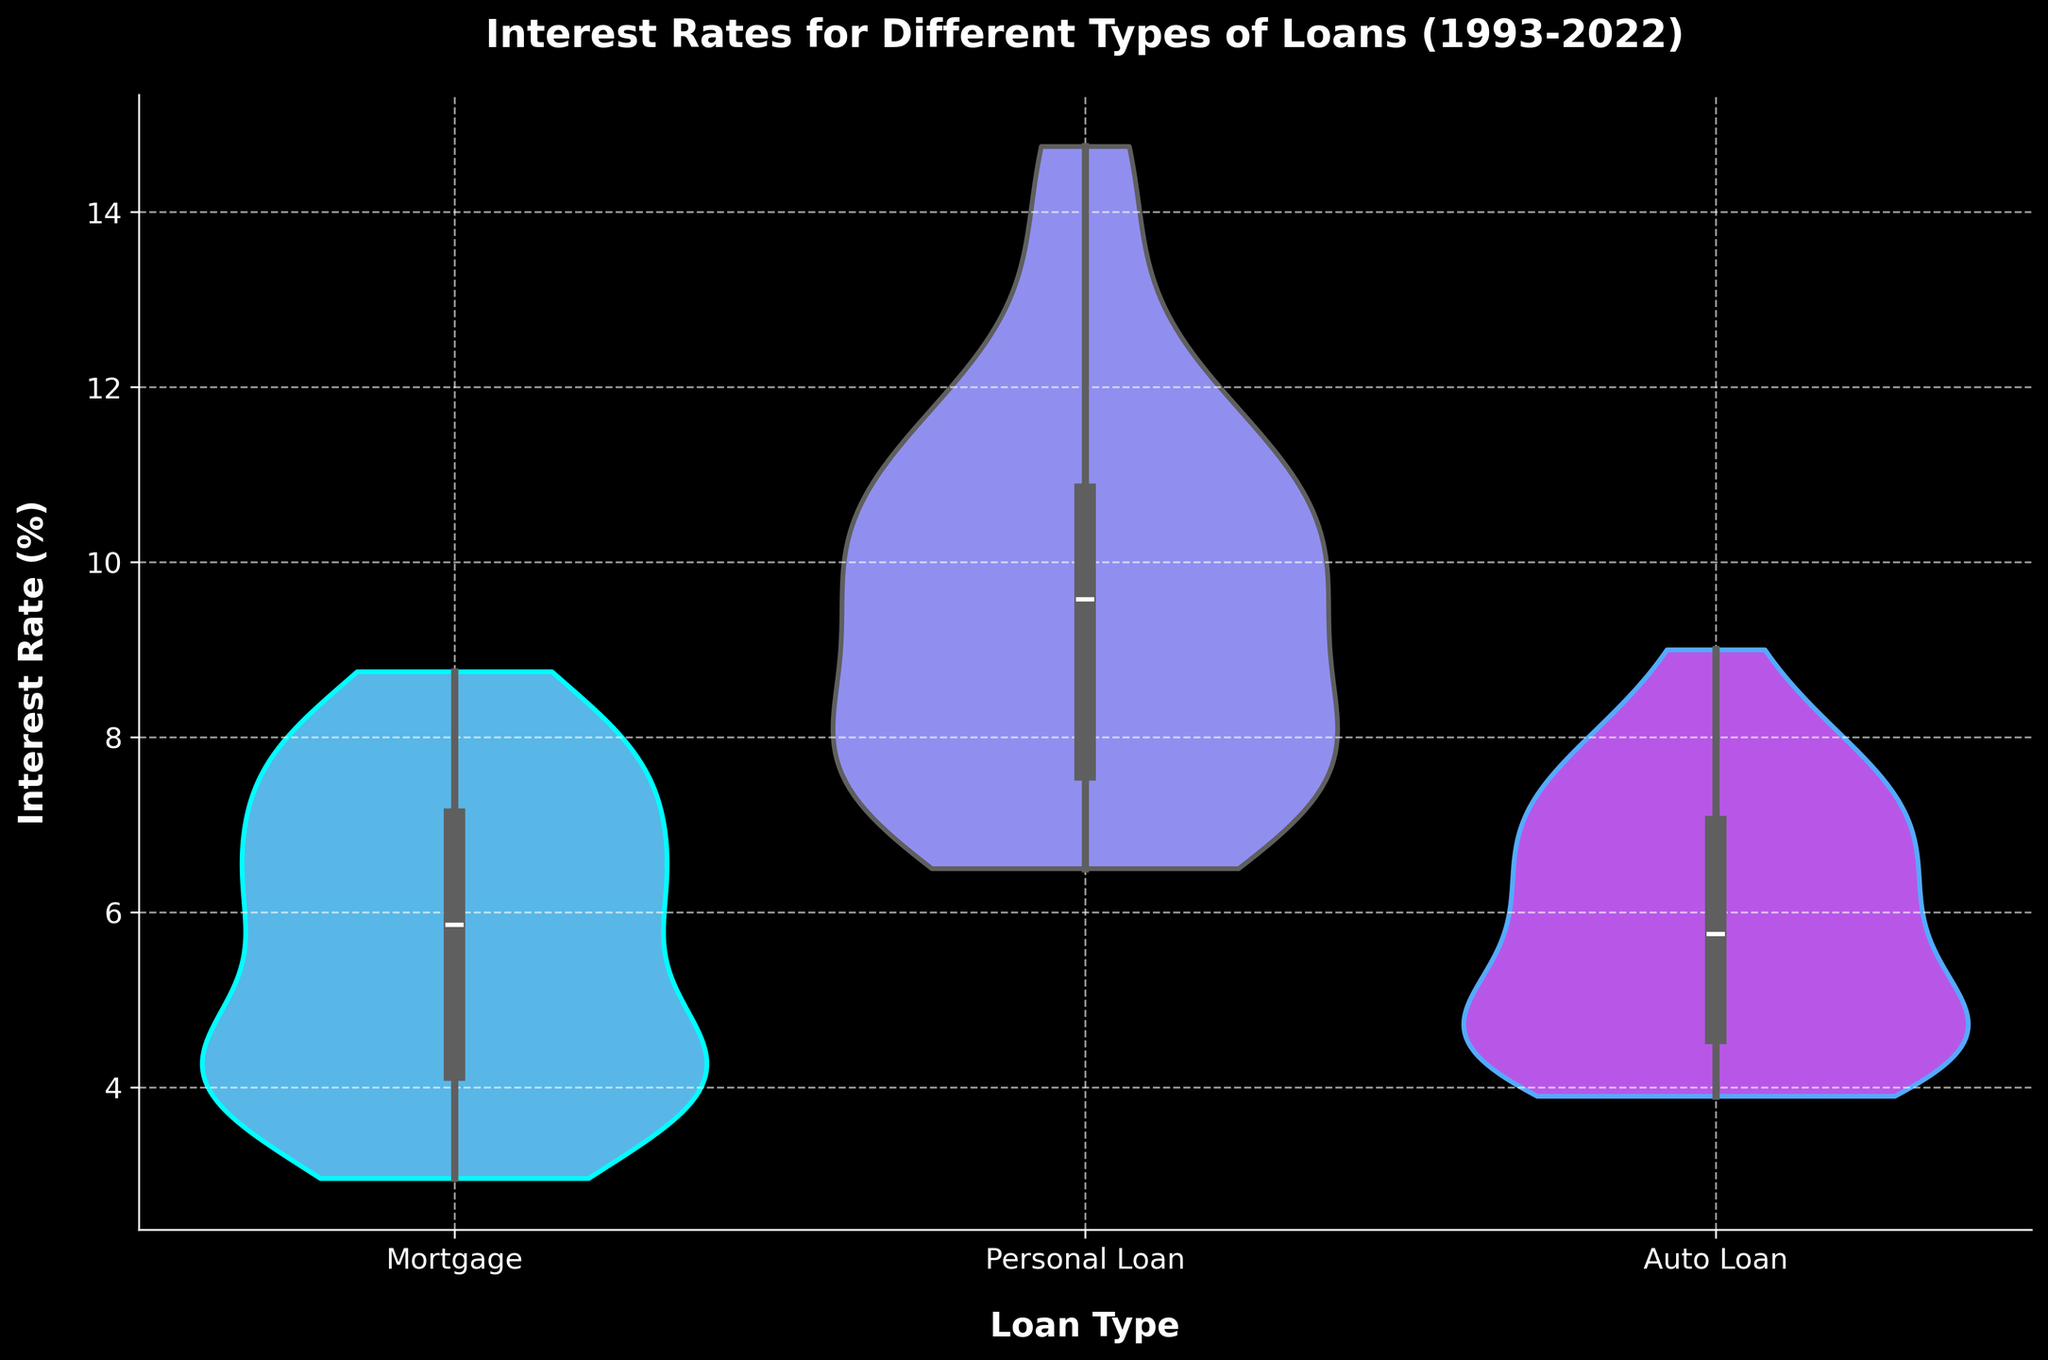what is the title of the figure? The title is usually displayed at the top of the figure. In this figure, it is clearly stated as 'Interest Rates for Different Types of Loans (1993-2022)'.
Answer: Interest Rates for Different Types of Loans (1993-2022) how many loan types are depicted in the figure? Each violin plot represents a different loan type. Counting the violin plots across the x-axis, we see three loan types.
Answer: Three which loan type has the widest spread in interest rates? The width of the violin plot indicates the distribution spread. The personal loan appears to have the widest spread compared to mortgages and auto loans.
Answer: Personal Loan which loan type has the lowest median interest rate? The median is represented by the middle line in the box plot overlay within each violin plot. Mortgage rates show the lowest median among the three loan types.
Answer: Mortgage which loan type exhibits the most variability (largest range) in interest rates? The range is the difference between the highest and lowest points within the violin plot. The auto loan has a significant spread especially in recent years, indicating the most variability.
Answer: Auto Loan by roughly how much did the interest rate for mortgages drop from its peak in the late 1990s to its lowest point? The highest interest rate for mortgages is around 8.75% in the late 1990s, and the lowest rate is around 2.96% in 2021. The drop is approximately 8.75% - 2.96%.
Answer: approximately 5.79% between auto loans and personal loans, which has a higher median interest rate over the years? Comparing the median lines in each box plot overlay, personal loans clearly have a higher median interest rate than auto loans.
Answer: Personal Loan what does the shape of the violin plot for mortgages imply about their rate distribution? The shape of the violin plot indicates the distribution of rates. A more uniform spread or higher density in the middle suggests a more consistent average rate, which is seen in mortgages.
Answer: Consistent average rate did personal loan interest rates show consistent decline over the years? Observing the overall shape and spread of the violin plot, the interest rates exhibit a general downward trend until a recent increase, indicating some periods of consistency but not a linear decline.
Answer: No, not consistent which loan type indicated the lowest overall interest rate in recent years? The bottom tip of the violin plots and the lower quartile in the box plot indicate the lowest interest rates. Mortgages show the lowest overall rates in recent years.
Answer: Mortgage 